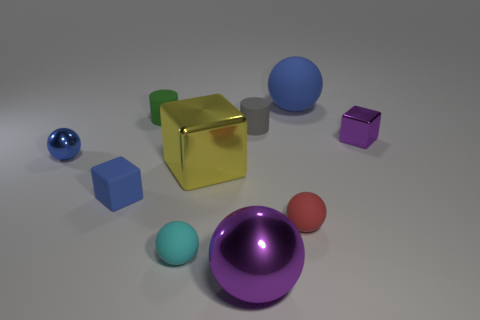There is a blue metallic object that is the same size as the green cylinder; what shape is it?
Give a very brief answer. Sphere. Are there any other things that have the same size as the green rubber thing?
Give a very brief answer. Yes. How many spheres are both behind the matte block and right of the blue cube?
Offer a very short reply. 1. What material is the purple cube that is the same size as the red matte sphere?
Offer a very short reply. Metal. There is a shiny thing that is in front of the small blue rubber object; is its size the same as the shiny cube in front of the tiny purple metal block?
Offer a very short reply. Yes. There is a small blue cube; are there any large blue rubber balls behind it?
Your answer should be compact. Yes. What color is the big ball behind the blue metallic object behind the yellow shiny object?
Offer a very short reply. Blue. Are there fewer large yellow metallic things than tiny rubber spheres?
Your answer should be compact. Yes. What number of blue matte things have the same shape as the green object?
Your answer should be very brief. 0. The other sphere that is the same size as the purple ball is what color?
Offer a very short reply. Blue. 